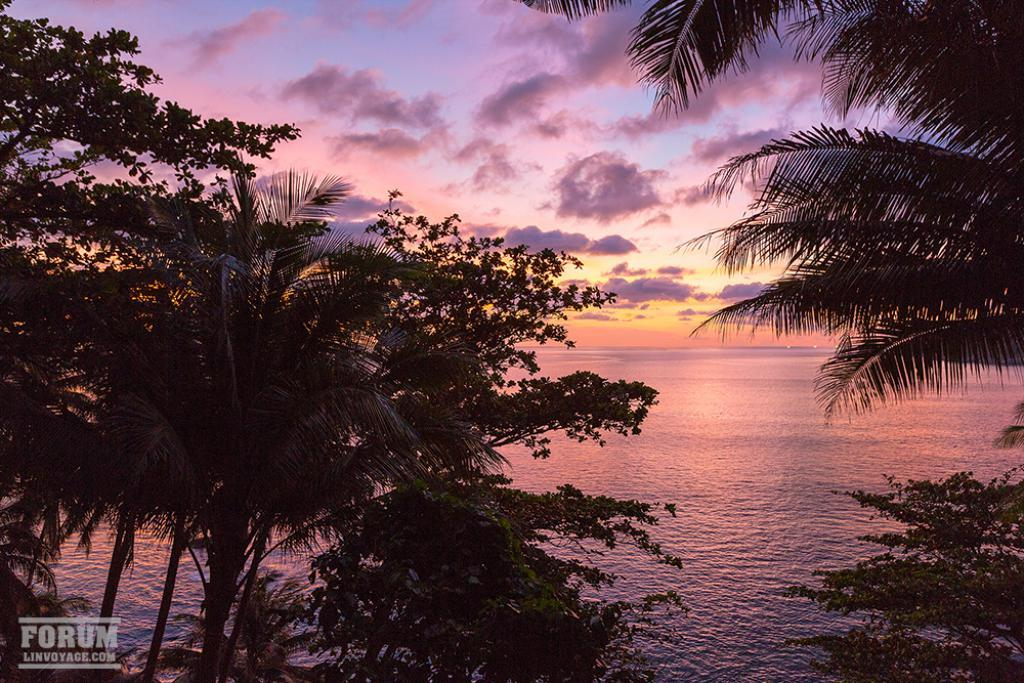What type of vegetation can be seen in the image? There is a tree and plants in the image. What natural element is present in the image? There is river water in the image. What can be seen in the background of the image? There is a sky visible in the background of the image, with clouds and sunshine present. What type of boundary can be seen in the image? There is no boundary present in the image; it features a tree, plants, river water, and a sky with clouds and sunshine. Who is the writer of the image? The image is not a written work, so there is no writer associated with it. 